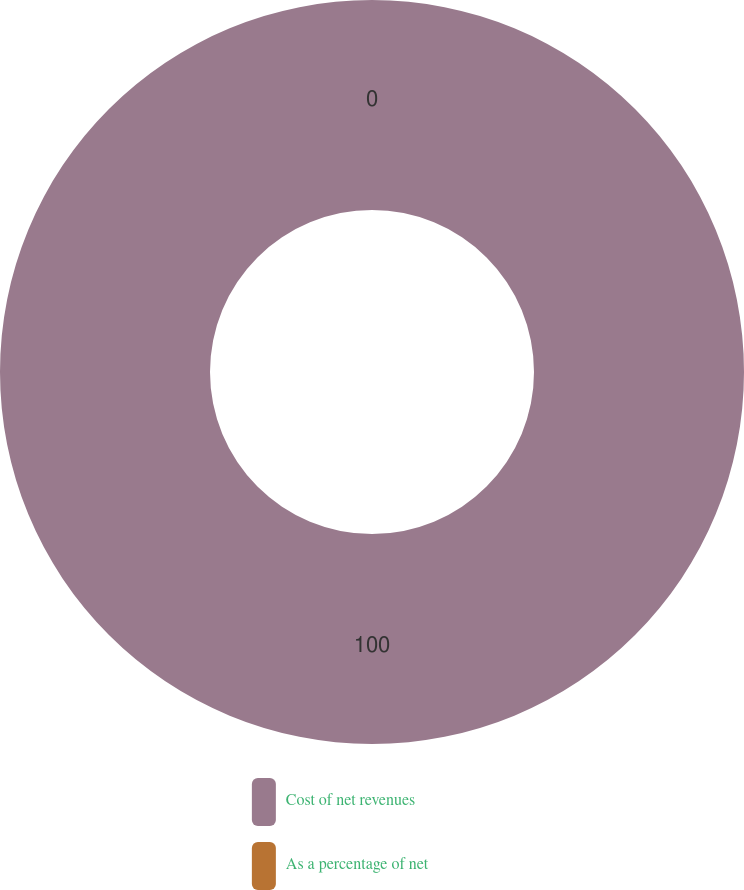Convert chart to OTSL. <chart><loc_0><loc_0><loc_500><loc_500><pie_chart><fcel>Cost of net revenues<fcel>As a percentage of net<nl><fcel>100.0%<fcel>0.0%<nl></chart> 